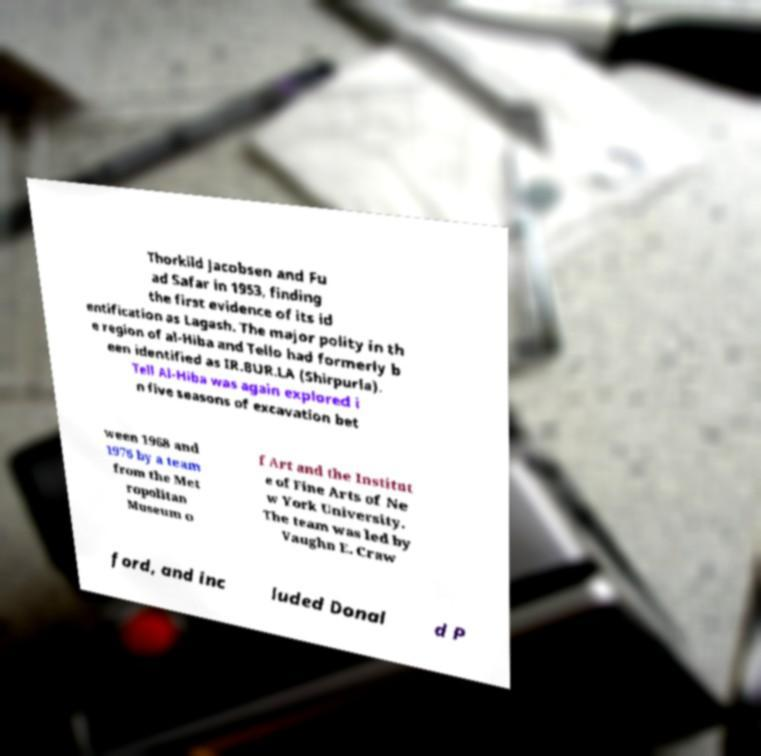Please identify and transcribe the text found in this image. Thorkild Jacobsen and Fu ad Safar in 1953, finding the first evidence of its id entification as Lagash. The major polity in th e region of al-Hiba and Tello had formerly b een identified as IR.BUR.LA (Shirpurla). Tell Al-Hiba was again explored i n five seasons of excavation bet ween 1968 and 1976 by a team from the Met ropolitan Museum o f Art and the Institut e of Fine Arts of Ne w York University. The team was led by Vaughn E. Craw ford, and inc luded Donal d P 